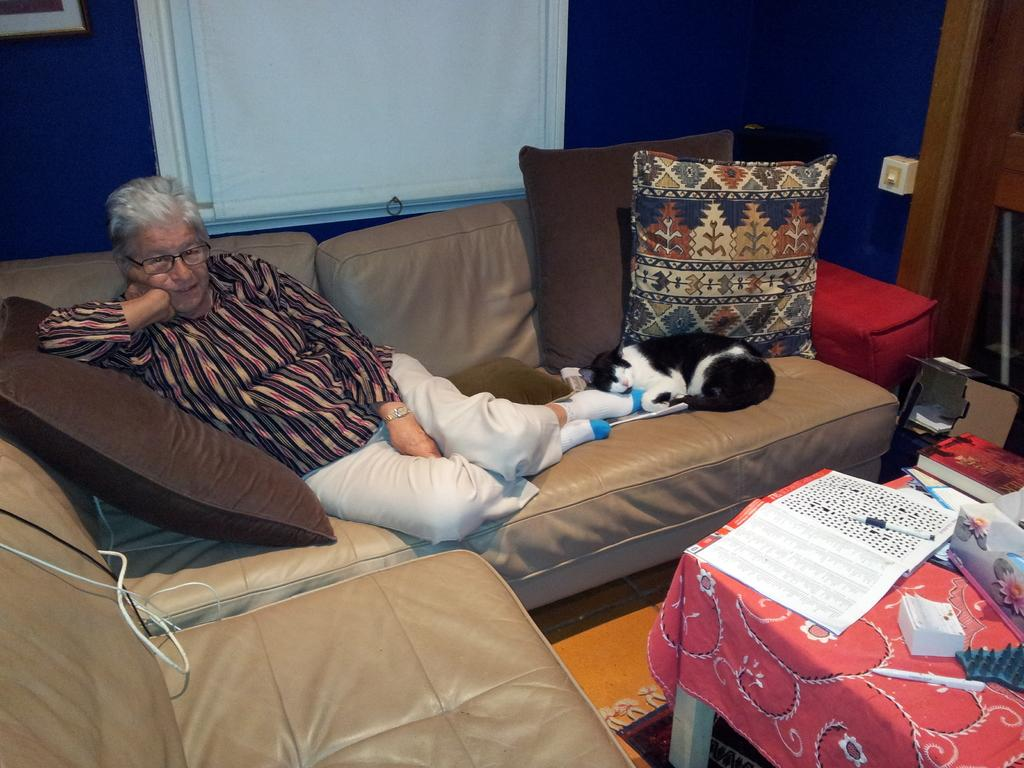Who or what can be seen in the image? There is a person and a cat in the image. Where are the person and the cat located? Both the person and the cat are on a sofa. What other items can be seen in the image? There are pillows, a tablecloth, books, and markers visible in the image. What can be seen on the floor in the image? The floor is visible in the image. What is in the background of the image? There is a frame and a wall in the background of the image. What type of noise can be heard coming from the iron in the image? There is no iron present in the image, so it is not possible to determine what noise might be heard. 